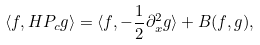Convert formula to latex. <formula><loc_0><loc_0><loc_500><loc_500>\langle f , H P _ { c } g \rangle = \langle f , - \frac { 1 } { 2 } \partial _ { x } ^ { 2 } g \rangle + B ( f , g ) ,</formula> 